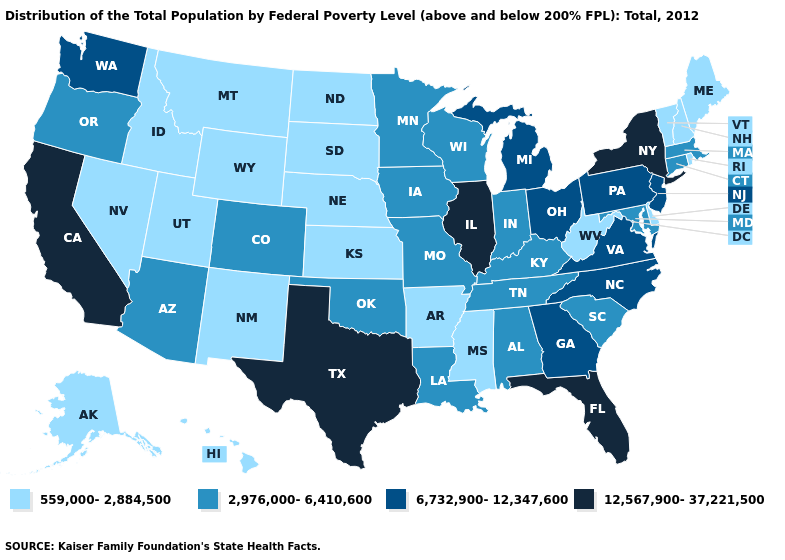Does Montana have a higher value than Mississippi?
Answer briefly. No. What is the lowest value in states that border Connecticut?
Quick response, please. 559,000-2,884,500. Does New Mexico have the highest value in the USA?
Give a very brief answer. No. Is the legend a continuous bar?
Concise answer only. No. Name the states that have a value in the range 559,000-2,884,500?
Short answer required. Alaska, Arkansas, Delaware, Hawaii, Idaho, Kansas, Maine, Mississippi, Montana, Nebraska, Nevada, New Hampshire, New Mexico, North Dakota, Rhode Island, South Dakota, Utah, Vermont, West Virginia, Wyoming. How many symbols are there in the legend?
Give a very brief answer. 4. Name the states that have a value in the range 559,000-2,884,500?
Answer briefly. Alaska, Arkansas, Delaware, Hawaii, Idaho, Kansas, Maine, Mississippi, Montana, Nebraska, Nevada, New Hampshire, New Mexico, North Dakota, Rhode Island, South Dakota, Utah, Vermont, West Virginia, Wyoming. Name the states that have a value in the range 559,000-2,884,500?
Be succinct. Alaska, Arkansas, Delaware, Hawaii, Idaho, Kansas, Maine, Mississippi, Montana, Nebraska, Nevada, New Hampshire, New Mexico, North Dakota, Rhode Island, South Dakota, Utah, Vermont, West Virginia, Wyoming. Name the states that have a value in the range 6,732,900-12,347,600?
Quick response, please. Georgia, Michigan, New Jersey, North Carolina, Ohio, Pennsylvania, Virginia, Washington. What is the highest value in states that border South Carolina?
Concise answer only. 6,732,900-12,347,600. Does the first symbol in the legend represent the smallest category?
Short answer required. Yes. Among the states that border Mississippi , does Tennessee have the lowest value?
Give a very brief answer. No. How many symbols are there in the legend?
Short answer required. 4. Does the map have missing data?
Answer briefly. No. Does the map have missing data?
Write a very short answer. No. 